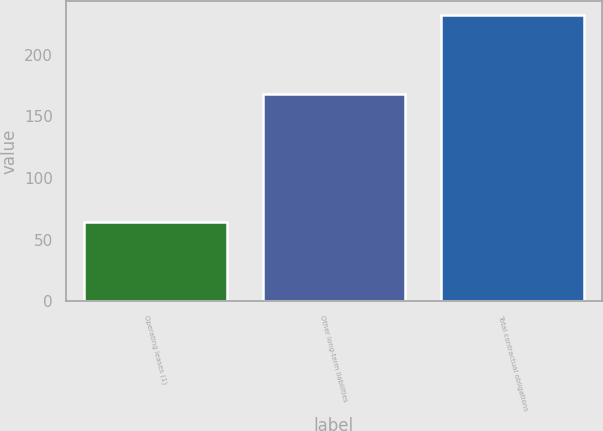Convert chart to OTSL. <chart><loc_0><loc_0><loc_500><loc_500><bar_chart><fcel>Operating leases (1)<fcel>Other long-term liabilities<fcel>Total contractual obligations<nl><fcel>64.2<fcel>168.3<fcel>232.5<nl></chart> 